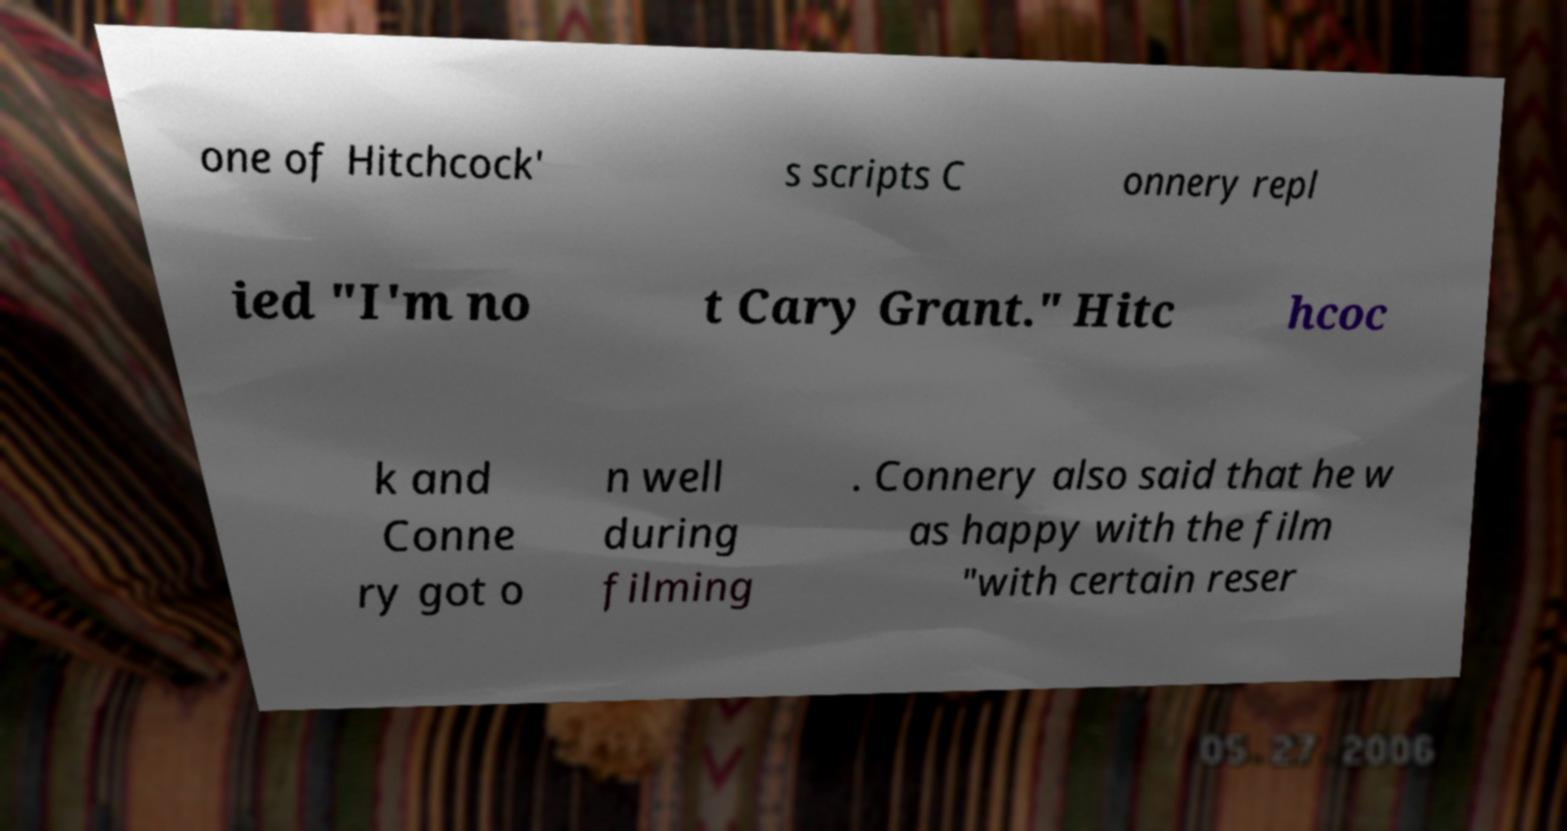Please identify and transcribe the text found in this image. one of Hitchcock' s scripts C onnery repl ied "I'm no t Cary Grant." Hitc hcoc k and Conne ry got o n well during filming . Connery also said that he w as happy with the film "with certain reser 